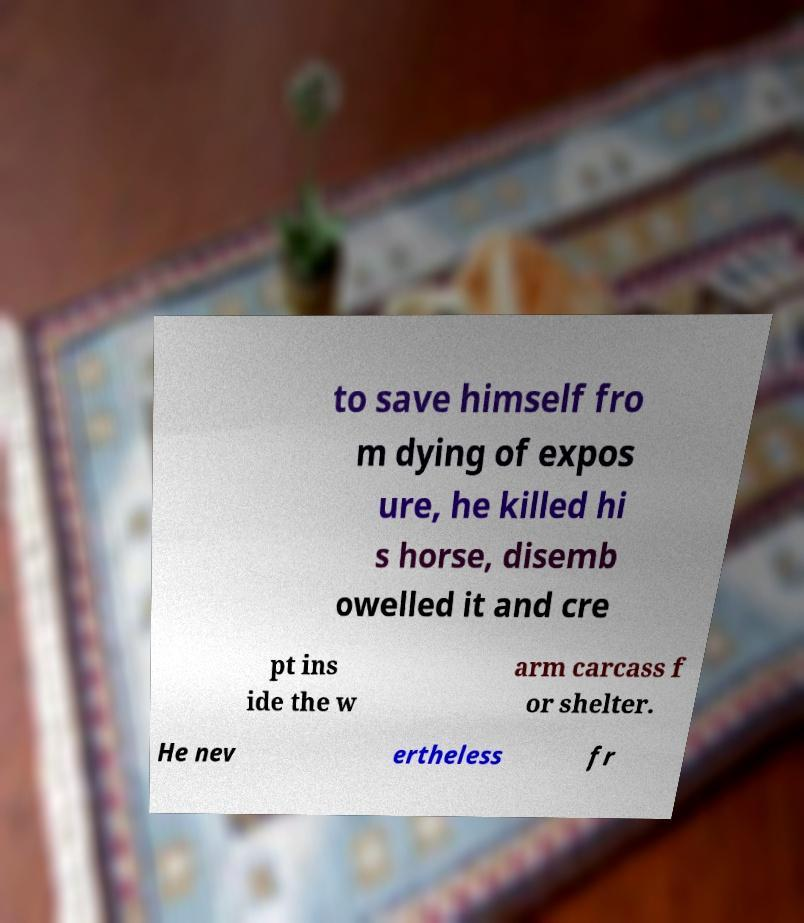Please read and relay the text visible in this image. What does it say? to save himself fro m dying of expos ure, he killed hi s horse, disemb owelled it and cre pt ins ide the w arm carcass f or shelter. He nev ertheless fr 